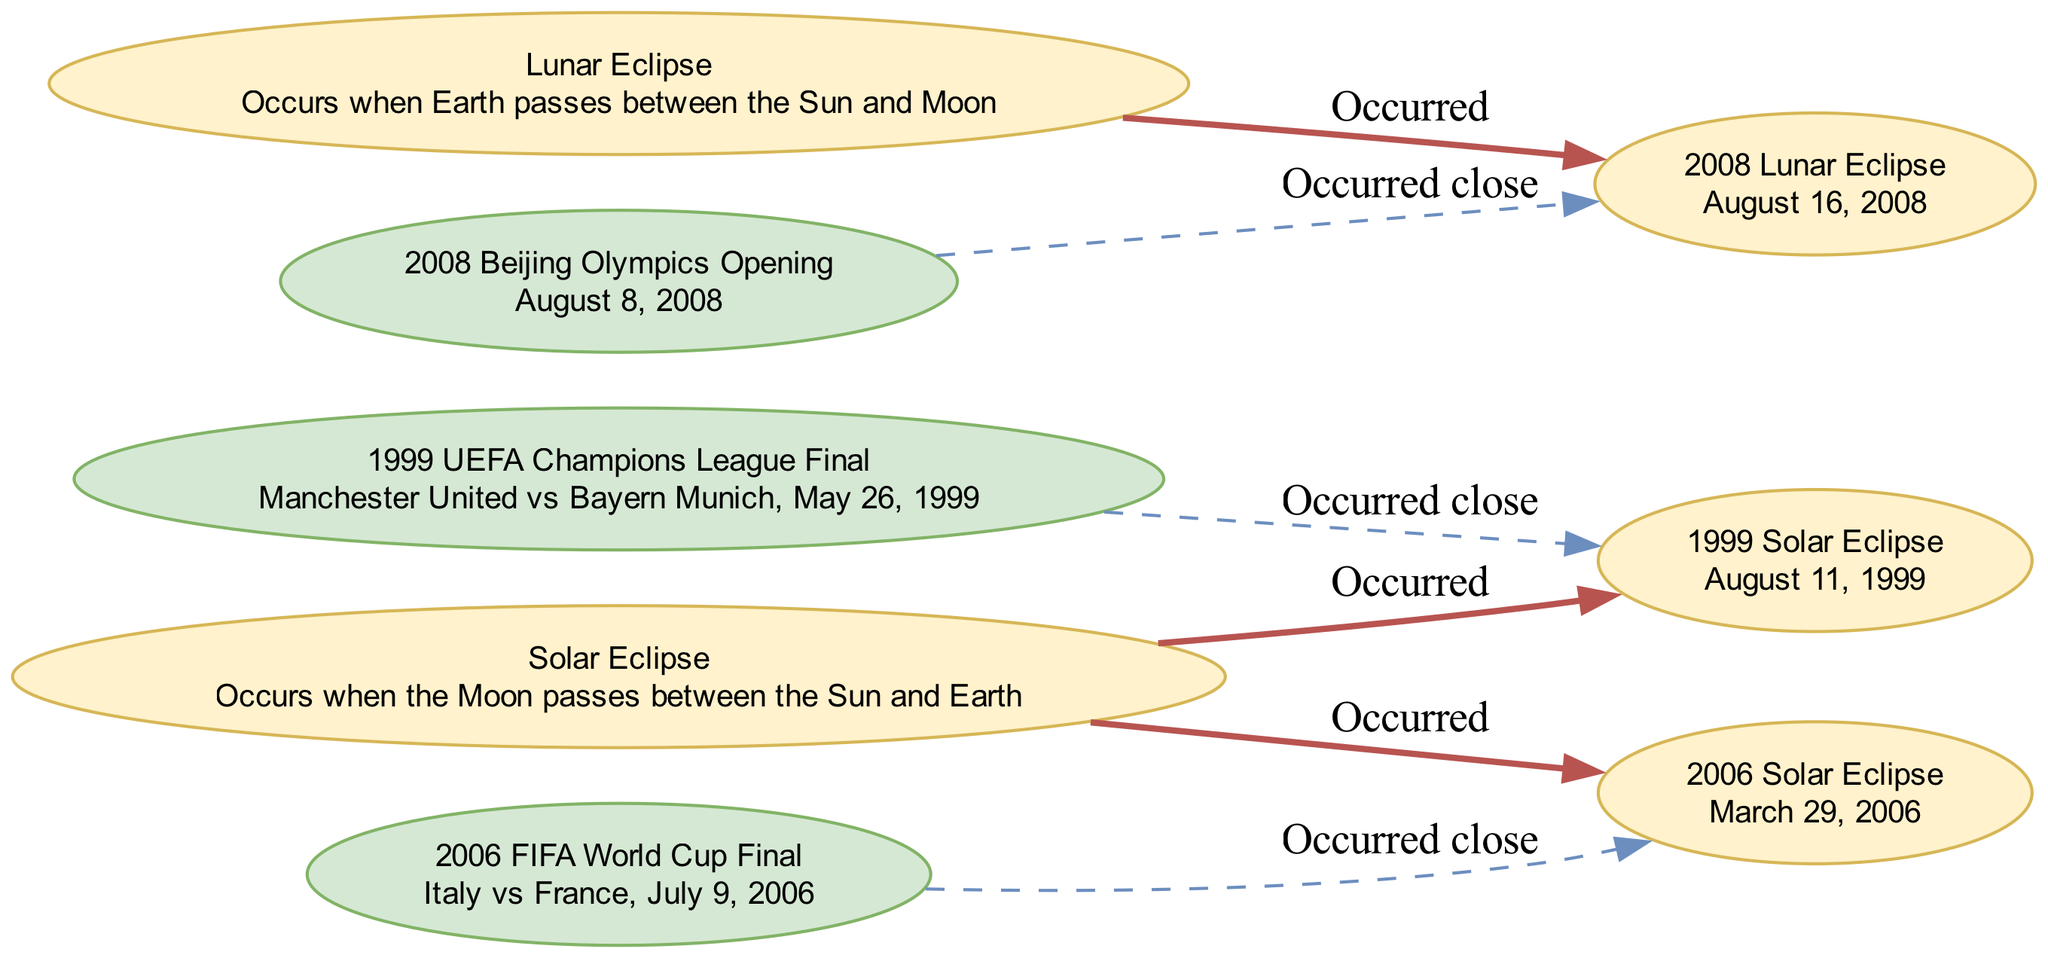What is the date of the 1999 Solar Eclipse? The diagram clearly lists the "1999 Solar Eclipse" under the eclipse section with its corresponding date as "August 11, 1999." Thus, by finding the node for the 1999 Solar Eclipse and reading its description, we find the date directly specified.
Answer: August 11, 1999 Which sports match occurred close to the 2006 Solar Eclipse? In the diagram, the "2006 Solar Eclipse" node is connected with a dashed edge to the "2006 FIFA World Cup Final," indicating that this match occurred closely in time to the solar eclipse. Therefore, by following the edges from the eclipse node, we can determine the related sports event.
Answer: 2006 FIFA World Cup Final How many nodes are there in the diagram? The diagram includes a total of 8 nodes that represent both eclipses and sports matches, as well as individual descriptions. By counting each of the nodes listed under "nodes" in the data provided, we arrive at the total count.
Answer: 8 What type of eclipse occurred on August 16, 2008? The diagram shows a connection from the "2008 Lunar Eclipse" node, which is labeled as having occurred on "August 16, 2008." Therefore, we can directly answer this by identifying the type of eclipse stated in that node.
Answer: Lunar Eclipse Which football match occurred close to the 1999 Solar Eclipse? The diagram indicates that the "1999 UEFA Champions League Final" occurred close to the "1999 Solar Eclipse" through a dashed edge connecting these two nodes. By following the relationship indicated in the diagram, we can identify the sports match linked to the eclipse.
Answer: 1999 UEFA Champions League Final Which eclipse is associated with the Beijing Olympics? The edge from "2008 Beijing Olympics Opening" connects to "2008 Lunar Eclipse," indicating that this specific lunar eclipse is associated with the opening ceremony of the Olympics. This relationship allows us to pinpoint the correct event linked in the diagram.
Answer: Lunar Eclipse Are there more solar eclipses or lunar eclipses represented in the diagram? The diagram contains two nodes representing solar eclipses ("1999 Solar Eclipse" and "2006 Solar Eclipse") and one node for a lunar eclipse ("2008 Lunar Eclipse"). By counting the eclipse nodes, we find that solar eclipses outnumber lunar eclipses in this representation.
Answer: More solar eclipses What is the date of the 2006 Solar Eclipse? The "2006 Solar Eclipse" node in the diagram directly describes its date as "March 29, 2006." We can identify this date by locating the eclipse node and reading the details provided.
Answer: March 29, 2006 